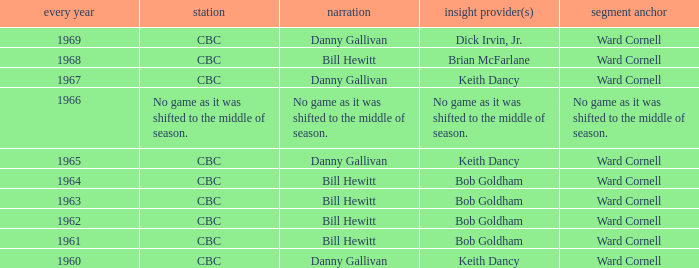Who gave the play by play commentary with studio host Ward Cornell? Danny Gallivan, Bill Hewitt, Danny Gallivan, Danny Gallivan, Bill Hewitt, Bill Hewitt, Bill Hewitt, Bill Hewitt, Danny Gallivan. 